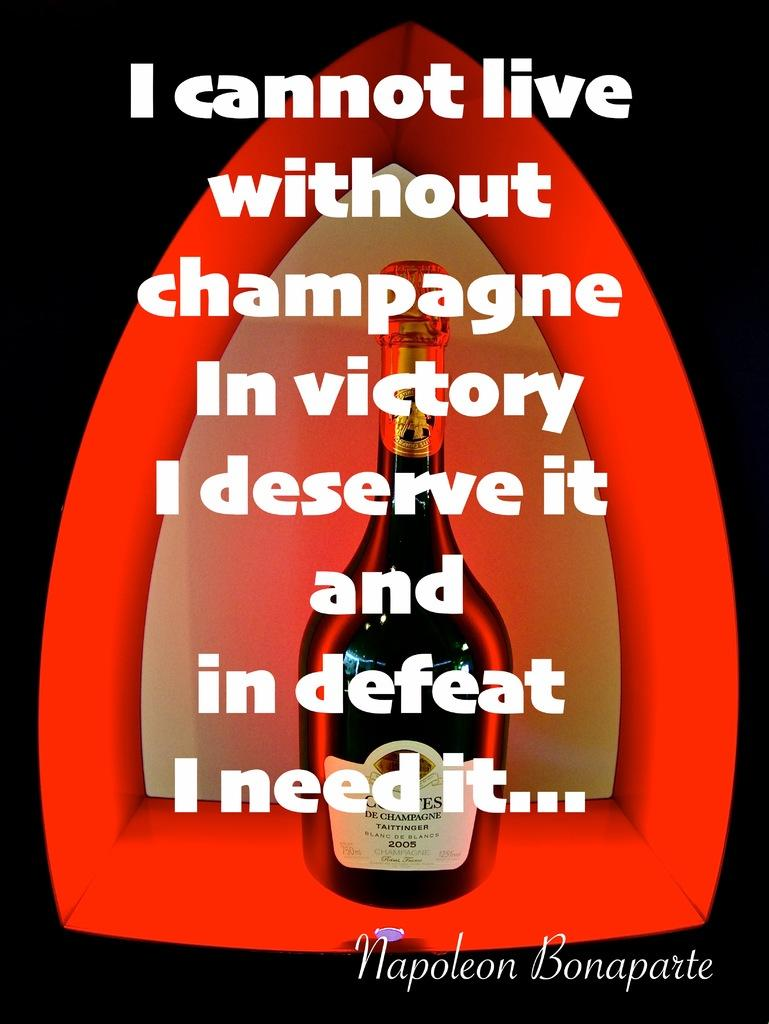Provide a one-sentence caption for the provided image. the word victory that is on a wine bottle. 